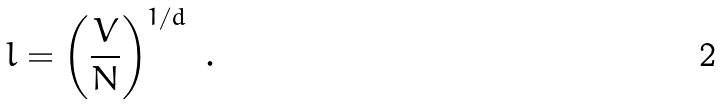Convert formula to latex. <formula><loc_0><loc_0><loc_500><loc_500>l = \left ( \frac { V } { N } \right ) ^ { 1 / d } \ .</formula> 